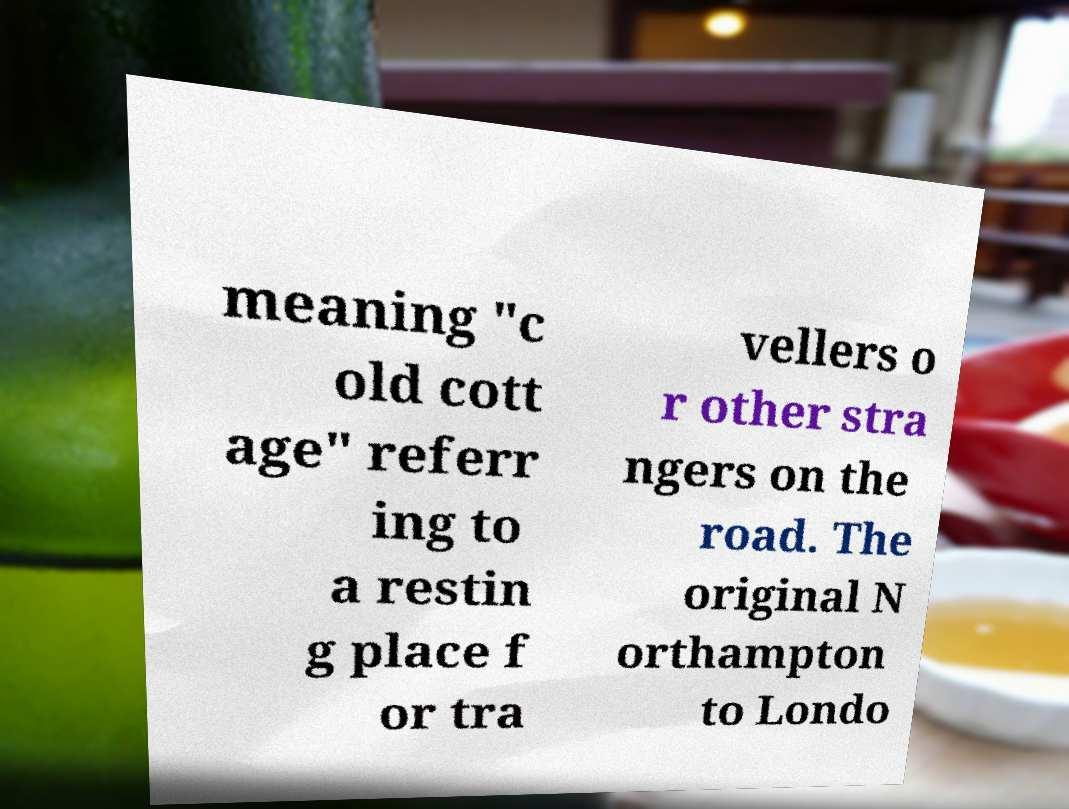I need the written content from this picture converted into text. Can you do that? meaning "c old cott age" referr ing to a restin g place f or tra vellers o r other stra ngers on the road. The original N orthampton to Londo 